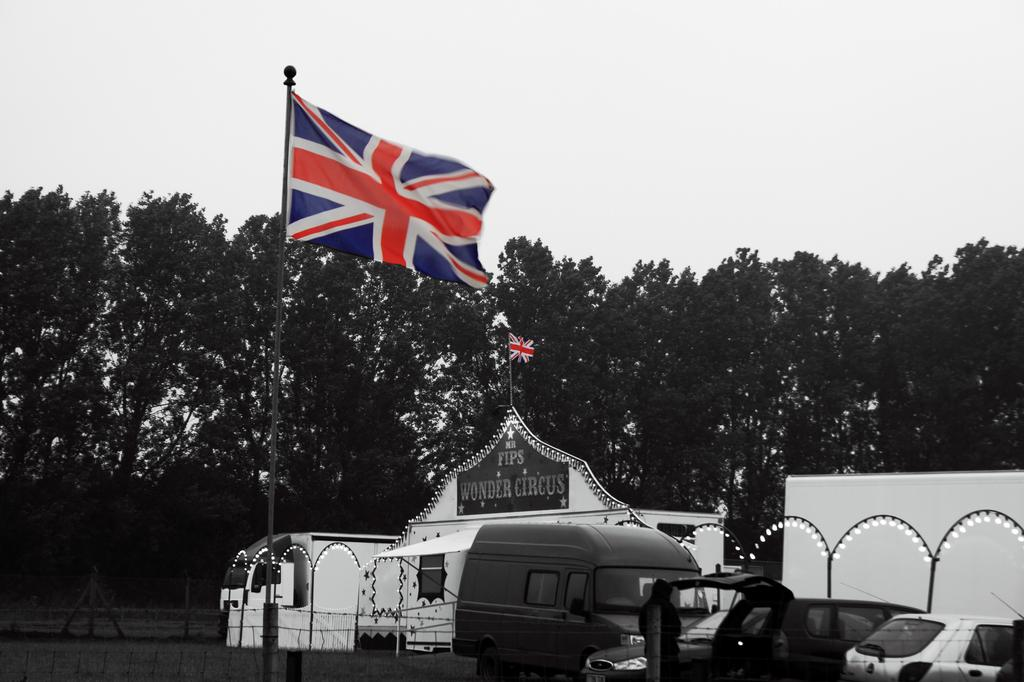What can be seen in the right corner of the image? There are vehicles in the right corner of the image. What is attached to the pole in the image? There are two flags attached to a pole. What type of natural scenery is visible in the background of the image? There are trees in the background of the image. What type of wood is the sheet made of in the image? There is no sheet or wood present in the image. Can you describe the owl perched on the tree in the image? There is no owl present in the image; only vehicles, flags, and trees are visible. 